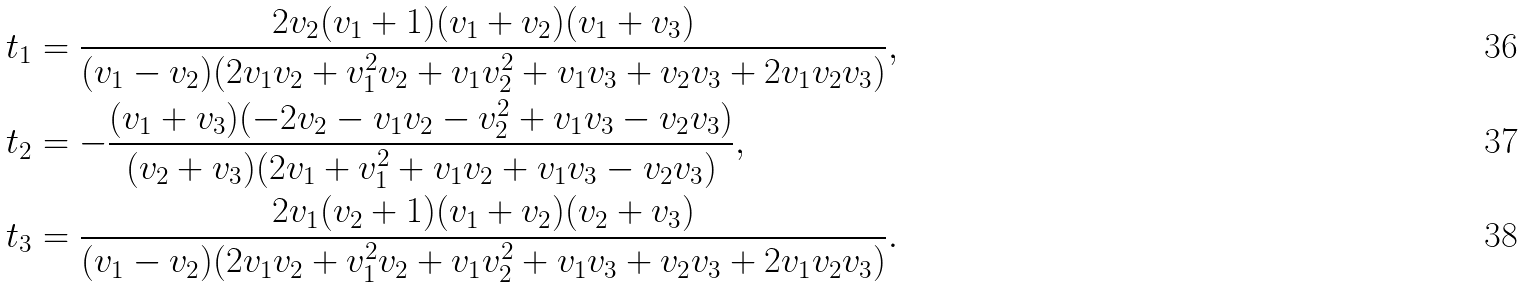<formula> <loc_0><loc_0><loc_500><loc_500>t _ { 1 } & = \frac { 2 v _ { 2 } ( v _ { 1 } + 1 ) ( v _ { 1 } + v _ { 2 } ) ( v _ { 1 } + v _ { 3 } ) } { ( v _ { 1 } - v _ { 2 } ) ( 2 v _ { 1 } v _ { 2 } + v _ { 1 } ^ { 2 } v _ { 2 } + v _ { 1 } v _ { 2 } ^ { 2 } + v _ { 1 } v _ { 3 } + v _ { 2 } v _ { 3 } + 2 v _ { 1 } v _ { 2 } v _ { 3 } ) } , \\ t _ { 2 } & = - \frac { ( v _ { 1 } + v _ { 3 } ) ( - 2 v _ { 2 } - v _ { 1 } v _ { 2 } - v _ { 2 } ^ { 2 } + v _ { 1 } v _ { 3 } - v _ { 2 } v _ { 3 } ) } { ( v _ { 2 } + v _ { 3 } ) ( 2 v _ { 1 } + v _ { 1 } ^ { 2 } + v _ { 1 } v _ { 2 } + v _ { 1 } v _ { 3 } - v _ { 2 } v _ { 3 } ) } , \\ t _ { 3 } & = \frac { 2 v _ { 1 } ( v _ { 2 } + 1 ) ( v _ { 1 } + v _ { 2 } ) ( v _ { 2 } + v _ { 3 } ) } { ( v _ { 1 } - v _ { 2 } ) ( 2 v _ { 1 } v _ { 2 } + v _ { 1 } ^ { 2 } v _ { 2 } + v _ { 1 } v _ { 2 } ^ { 2 } + v _ { 1 } v _ { 3 } + v _ { 2 } v _ { 3 } + 2 v _ { 1 } v _ { 2 } v _ { 3 } ) } .</formula> 